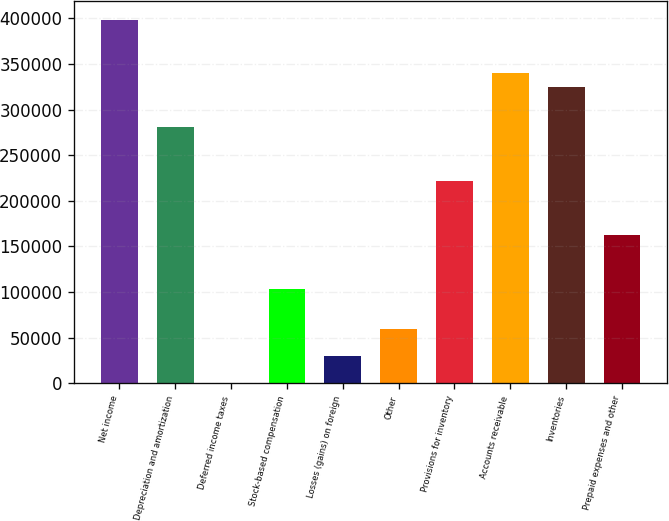Convert chart. <chart><loc_0><loc_0><loc_500><loc_500><bar_chart><fcel>Net income<fcel>Depreciation and amortization<fcel>Deferred income taxes<fcel>Stock-based compensation<fcel>Losses (gains) on foreign<fcel>Other<fcel>Provisions for inventory<fcel>Accounts receivable<fcel>Inventories<fcel>Prepaid expenses and other<nl><fcel>398540<fcel>280573<fcel>401<fcel>103622<fcel>29892.8<fcel>59384.6<fcel>221590<fcel>339557<fcel>324811<fcel>162606<nl></chart> 